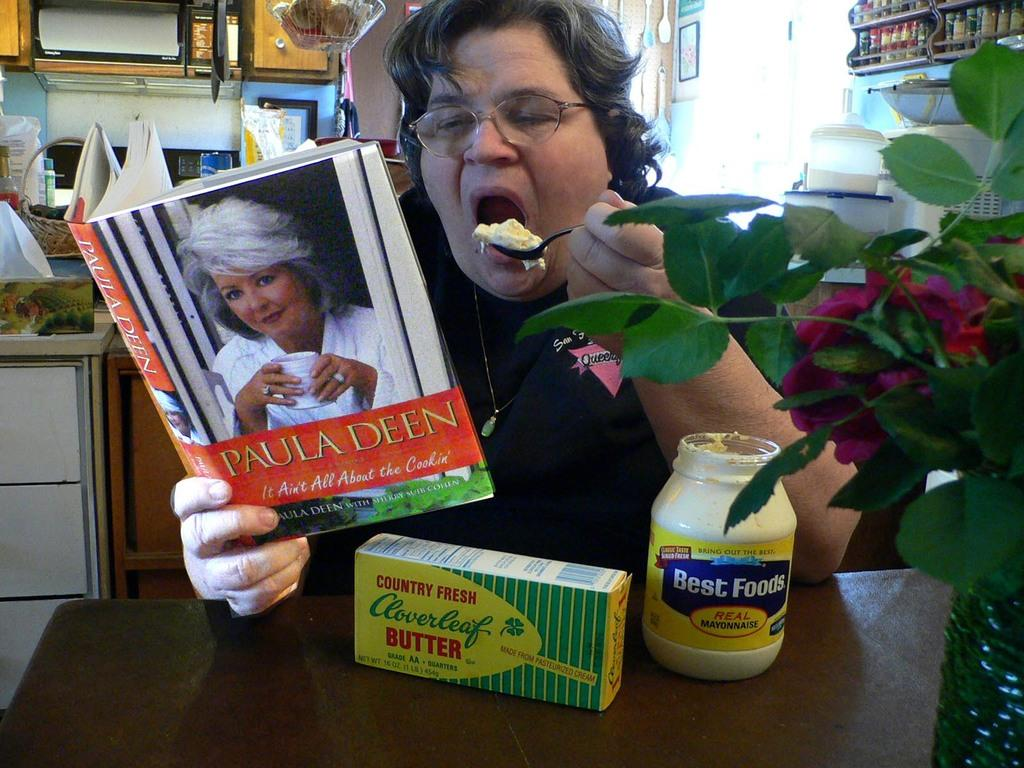<image>
Write a terse but informative summary of the picture. A fat woman shovels a spoon full of mayo into her mouth while reading Paula Deen's book. 